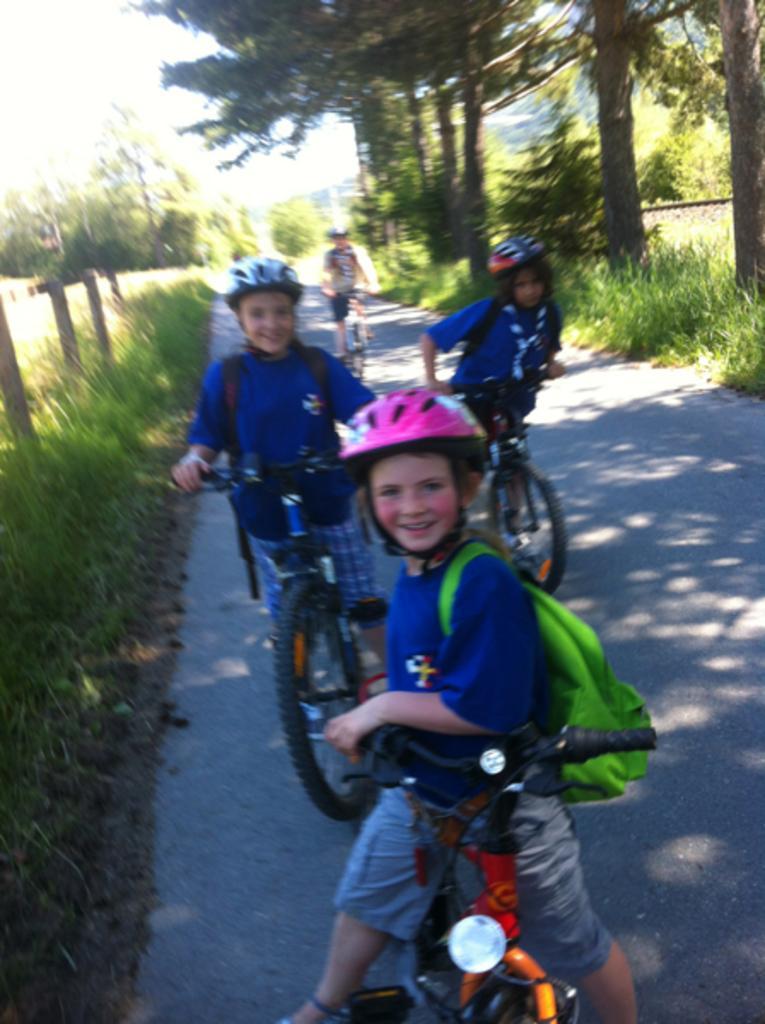Describe this image in one or two sentences. In this picture I can see there is a walkway and there are few kids riding the bicycle on it, they are wearing helmets and bags, the kid at the center is smiling and there is grass on both sides of the walkway, there are few trees and the backdrop is blurred. 